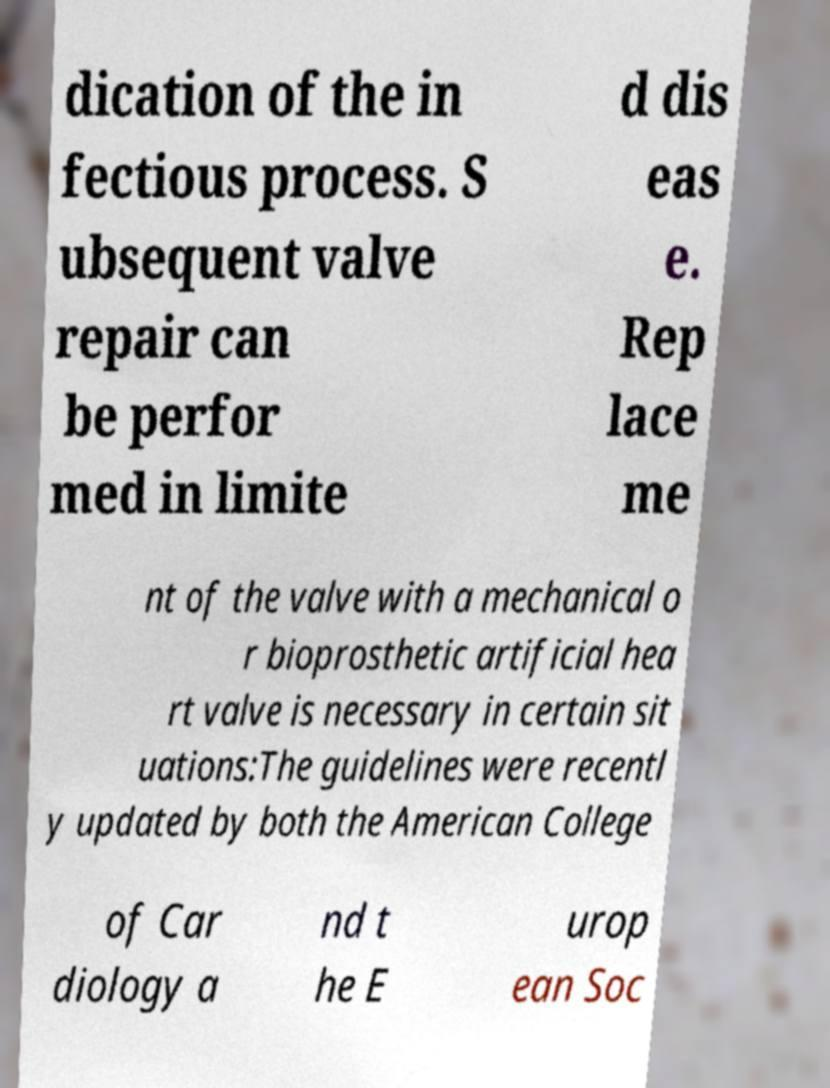Could you assist in decoding the text presented in this image and type it out clearly? dication of the in fectious process. S ubsequent valve repair can be perfor med in limite d dis eas e. Rep lace me nt of the valve with a mechanical o r bioprosthetic artificial hea rt valve is necessary in certain sit uations:The guidelines were recentl y updated by both the American College of Car diology a nd t he E urop ean Soc 